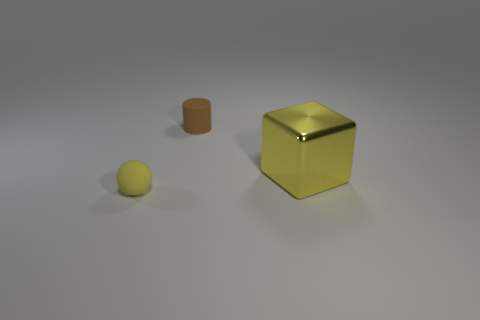There is a thing that is the same color as the large shiny block; what size is it? small 